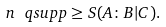Convert formula to latex. <formula><loc_0><loc_0><loc_500><loc_500>n \, \ q s u p p \geq S ( A \colon B | C ) .</formula> 